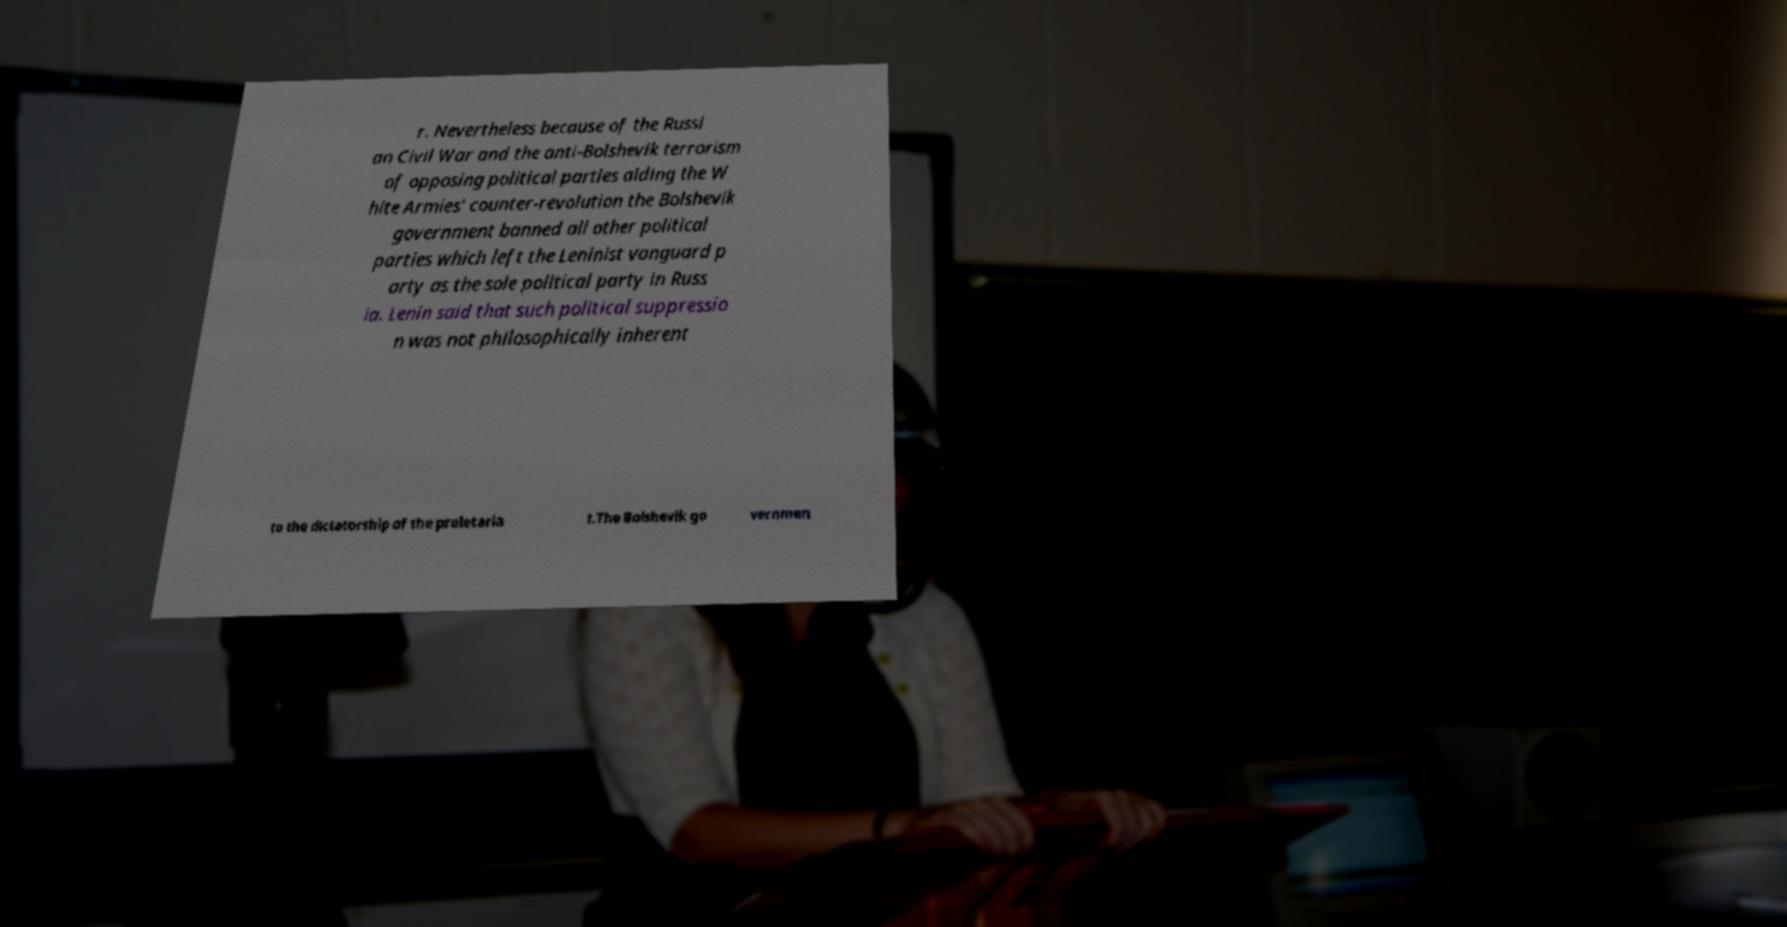Can you accurately transcribe the text from the provided image for me? r. Nevertheless because of the Russi an Civil War and the anti-Bolshevik terrorism of opposing political parties aiding the W hite Armies' counter-revolution the Bolshevik government banned all other political parties which left the Leninist vanguard p arty as the sole political party in Russ ia. Lenin said that such political suppressio n was not philosophically inherent to the dictatorship of the proletaria t.The Bolshevik go vernmen 